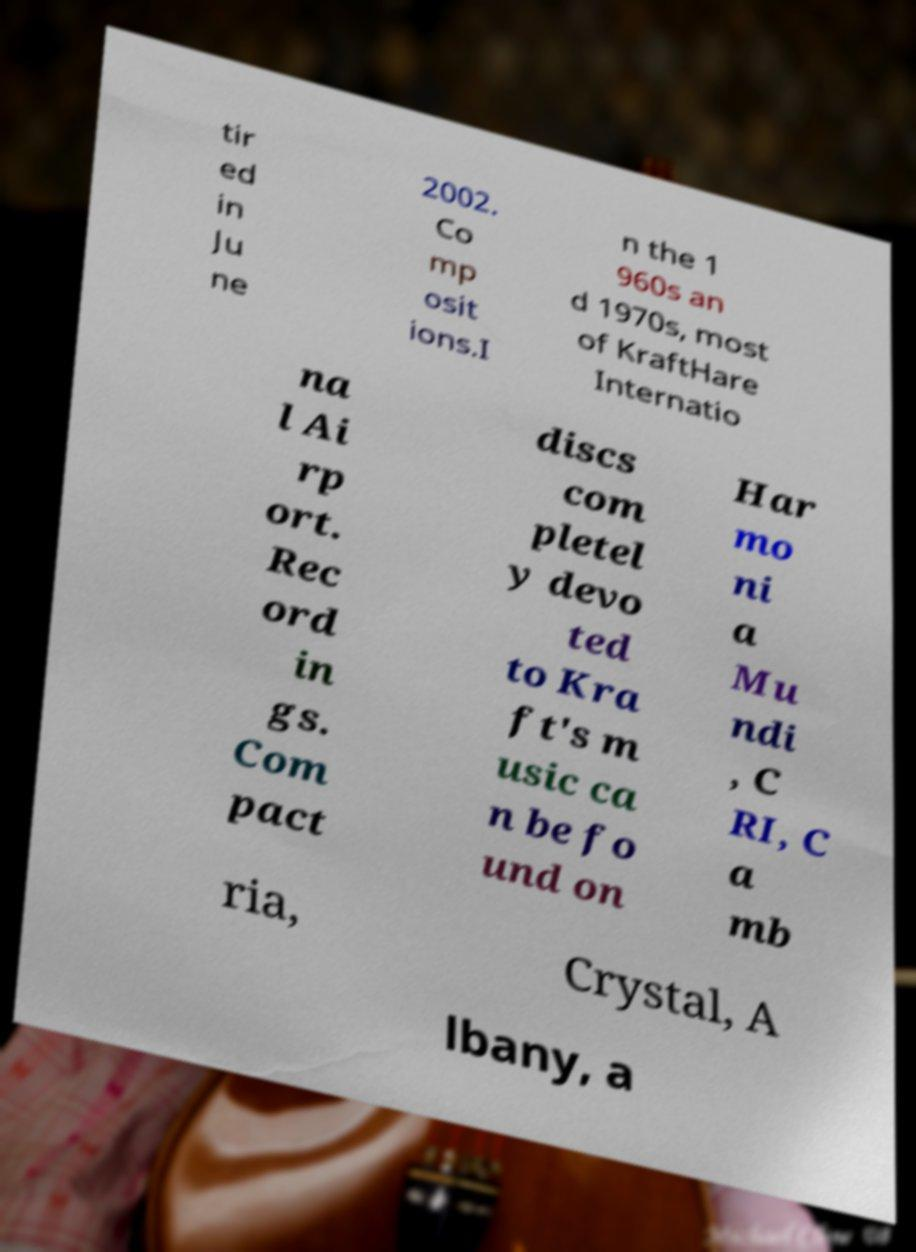I need the written content from this picture converted into text. Can you do that? tir ed in Ju ne 2002. Co mp osit ions.I n the 1 960s an d 1970s, most of KraftHare Internatio na l Ai rp ort. Rec ord in gs. Com pact discs com pletel y devo ted to Kra ft's m usic ca n be fo und on Har mo ni a Mu ndi , C RI, C a mb ria, Crystal, A lbany, a 